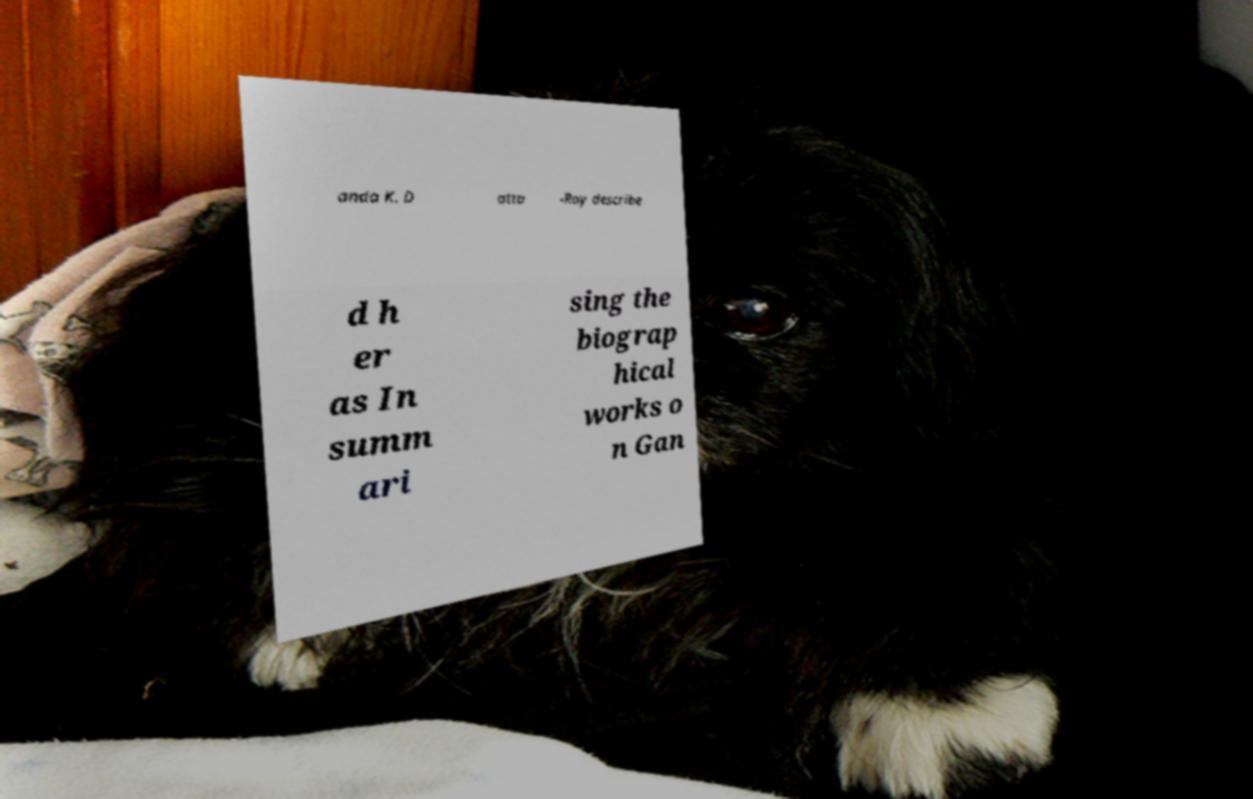Can you read and provide the text displayed in the image?This photo seems to have some interesting text. Can you extract and type it out for me? anda K. D atta -Ray describe d h er as In summ ari sing the biograp hical works o n Gan 